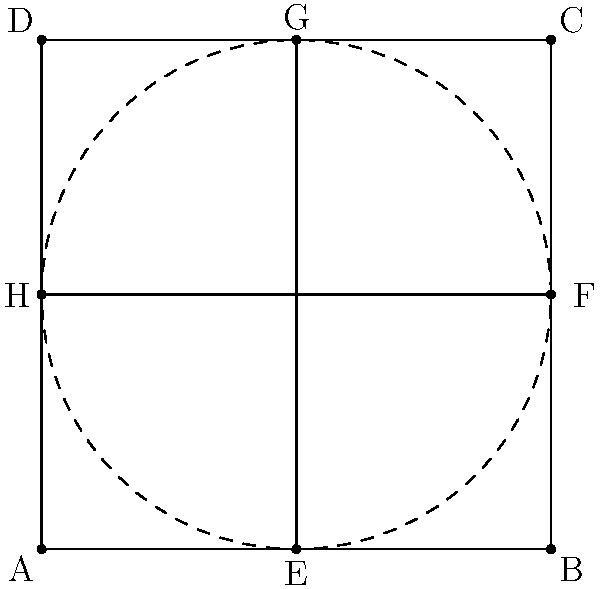In classical art compositions, symmetry often plays a crucial role. Consider the above diagram representing a simplified version of Leonardo da Vinci's "Vitruvian Man" composition. Which geometric transformation, when applied to triangle AEH, would produce triangle BGF? To solve this problem, we need to analyze the geometric relationships within the composition:

1. First, observe that the diagram is inscribed in a square ABCD.
2. The circle is centered at the midpoint of the square, point (2,2).
3. Triangle AEH is in the bottom-left quadrant of the square.
4. Triangle BGF is in the top-right quadrant of the square.

To transform triangle AEH into triangle BGF:

1. Rotate triangle AEH by 180° around the center point (2,2).
   This rotation brings point A to C, E to G, and H to F.
2. After rotation, we get the exact position and orientation of triangle BGF.

Therefore, the transformation is a 180° rotation around the center point (2,2).

In classical art, this type of symmetry is often used to create balance and harmony in compositions. The Vitruvian Man, in particular, showcases the ideal human proportions and the symmetry of the human body.
Answer: 180° rotation around (2,2) 